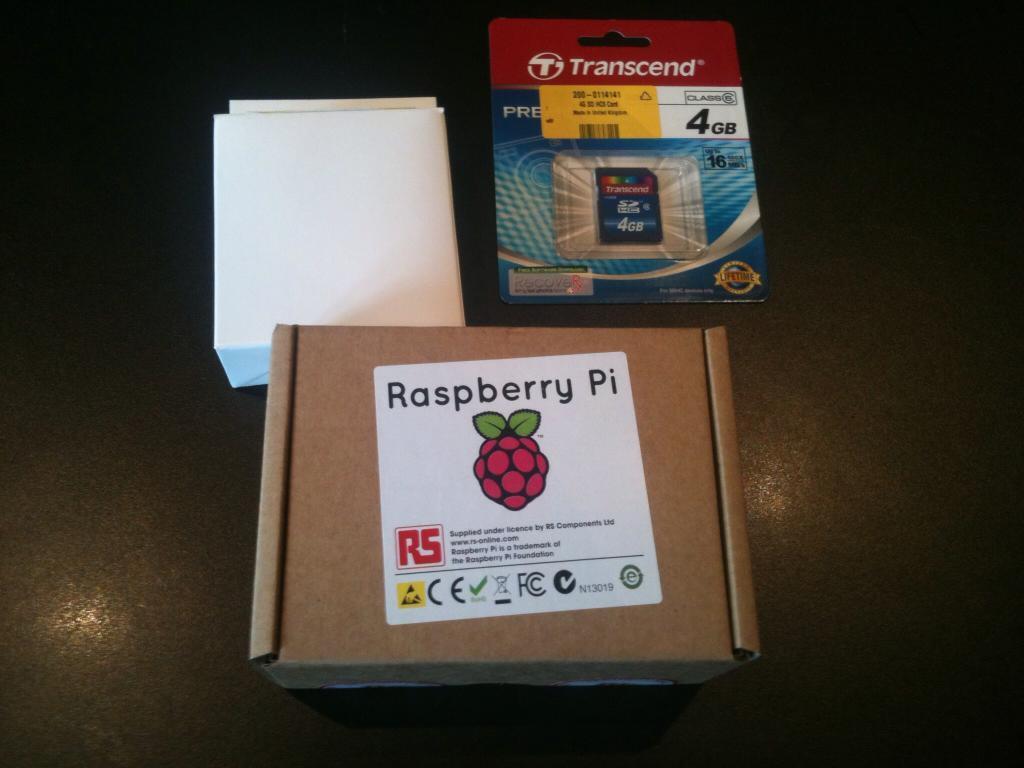How would you summarize this image in a sentence or two? In this image at the bottom there is a table, on the table there are two boxes and one packet. 